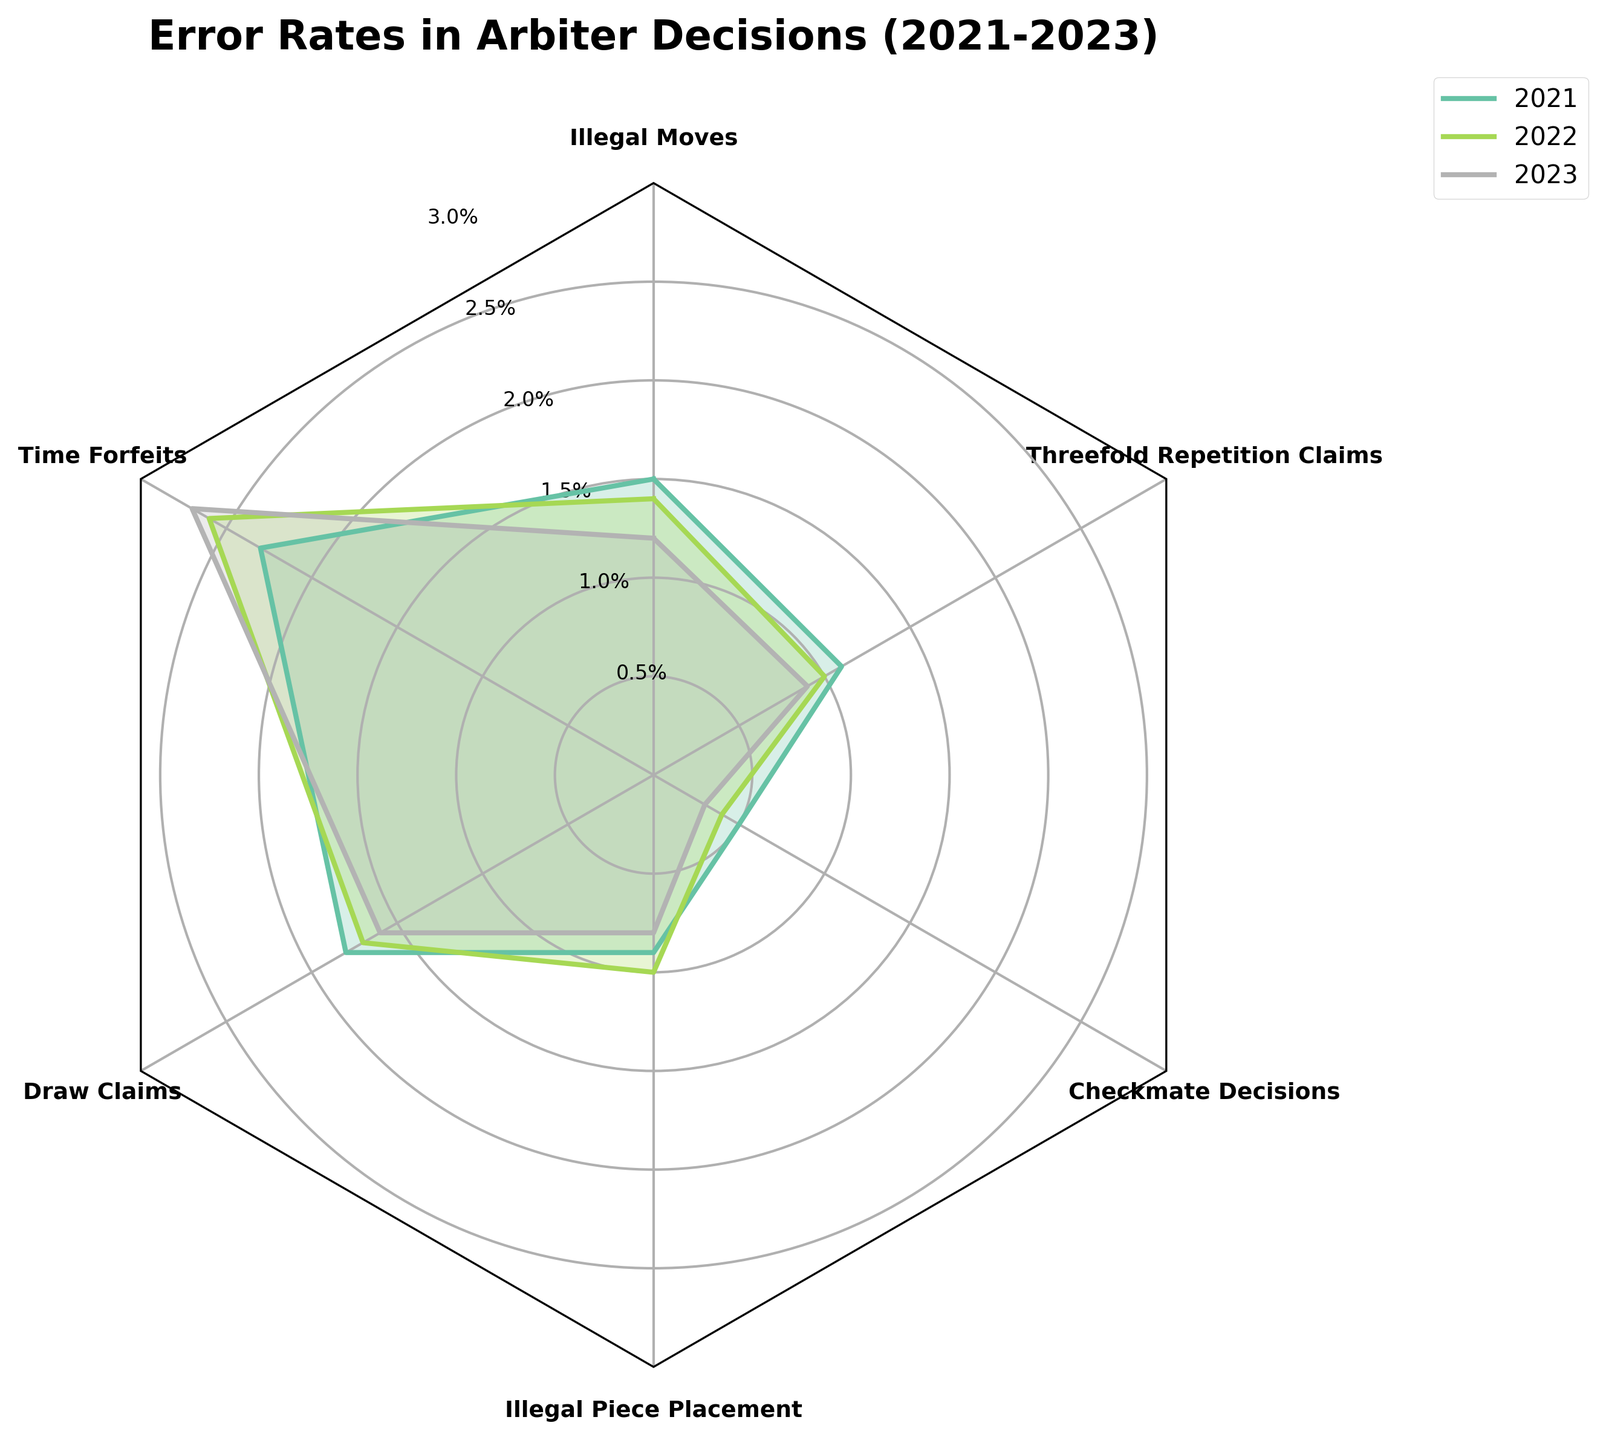What is the title of the radar chart? The title is the text displayed at the top of the radar chart. In this case, it reads "Error Rates in Arbiter Decisions (2021-2023)".
Answer: Error Rates in Arbiter Decisions (2021-2023) Whose error rate decreased the most from 2021 to 2023? To answer this question, compare the error rates of each type from 2021 to 2023. Illegal Moves decreased from 1.5% to 1.2%, Time Forfeits increased, Draw Claims decreased from 1.8% to 1.6%, Illegal Piece Placement decreased from 0.9% to 0.8%, Checkmate Decisions decreased from 0.5% to 0.3%, and Threefold Repetition Claims decreased from 1.1% to 0.9%. Checkmate Decisions had the largest reduction.
Answer: Checkmate Decisions Which type of error had the highest rate in 2023? Examine the outermost layer of the radar chart to identify the highest value for 2023. Time Forfeits had the highest rate at 2.7%.
Answer: Time Forfeits How many types of errors are displayed in the radar chart? The number of segments in the radar chart represents the different types of errors. Counting these segments gives us the total number of error types displayed.
Answer: Six Between which years did the error rate for Illegal Moves decrease and by how much? Look at the error rates for Illegal Moves. It was 1.5% in 2021, 1.4% in 2022, and 1.2% in 2023. Subtract the rates to find the decrease: 1.5% - 1.4% = 0.1% from 2021 to 2022, and 1.4% - 1.2% = 0.2% from 2022 to 2023.
Answer: 0.1% (2021-2022), 0.2% (2022-2023) For which type of error did the rate remain almost constant across all years? Compare the rates for all types of errors across 2021, 2022, and 2023. Illegal Piece Placement rates were 0.9%, 1.0%, and 0.8% respectively, showing the least fluctuation.
Answer: Illegal Piece Placement What is the average error rate for Draw Claims across the three years? Add the error rates for Draw Claims for each year and divide by the number of years: (1.8 + 1.7 + 1.6) / 3 = 5.1 / 3 = 1.7%
Answer: 1.7% In which year were the error rates for Time Forfeits the highest? Check the values plotted for Time Forfeits: 2.3% in 2021, 2.6% in 2022, and 2.7% in 2023. The highest rate was in 2023.
Answer: 2023 Which error type improved consistently over the three years? Look for types where the error rate decreases each subsequent year. For Checkmate Decisions, the rates are 0.5%, 0.4%, and then 0.3%, showing consistent improvement.
Answer: Checkmate Decisions 